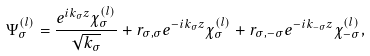<formula> <loc_0><loc_0><loc_500><loc_500>\Psi _ { \sigma } ^ { ( l ) } = \frac { e ^ { i k _ { \sigma } z } \chi _ { \sigma } ^ { ( l ) } } { \sqrt { k _ { \sigma } } } + r _ { \sigma , \sigma } e ^ { - i k _ { \sigma } z } \chi _ { \sigma } ^ { ( l ) } + r _ { \sigma , - \sigma } e ^ { - i k _ { - \sigma } z } \chi _ { - \sigma } ^ { ( l ) } ,</formula> 